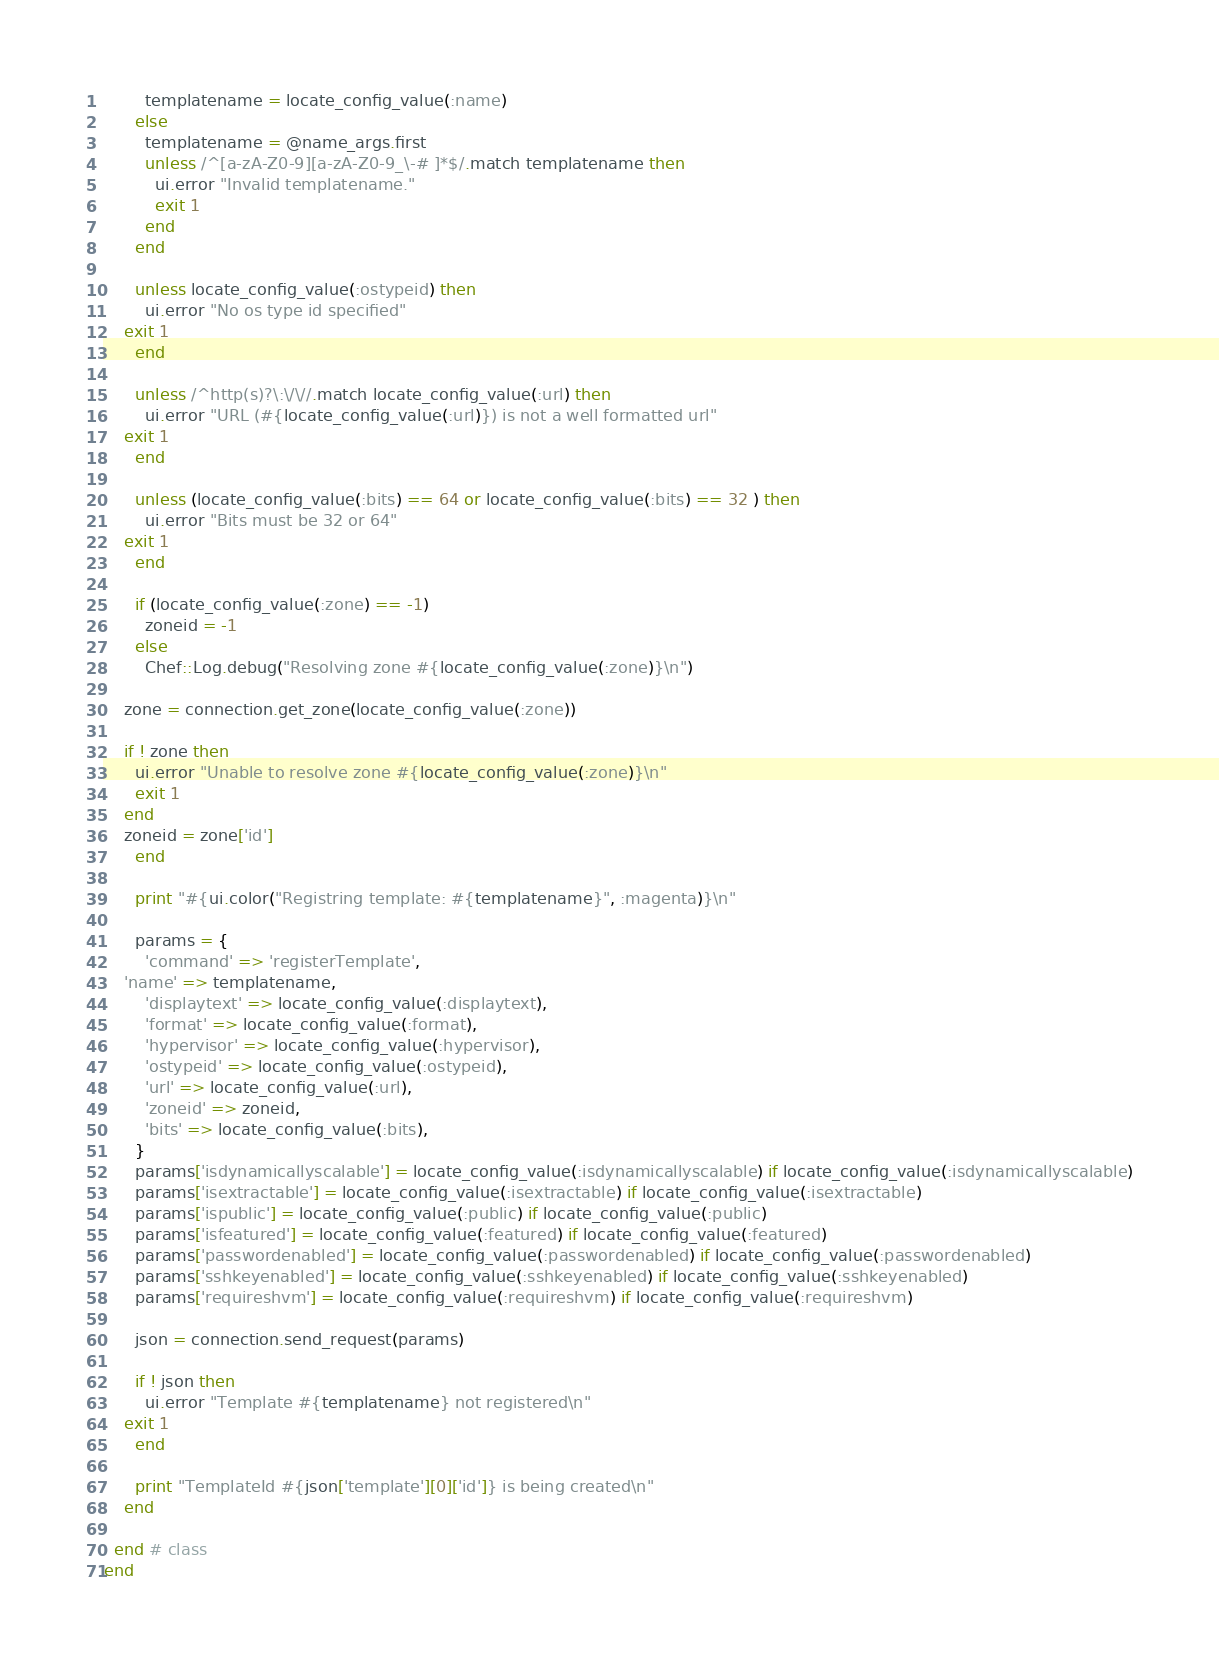<code> <loc_0><loc_0><loc_500><loc_500><_Ruby_>        templatename = locate_config_value(:name)
      else
        templatename = @name_args.first
        unless /^[a-zA-Z0-9][a-zA-Z0-9_\-# ]*$/.match templatename then
          ui.error "Invalid templatename."
          exit 1
        end
      end

      unless locate_config_value(:ostypeid) then
        ui.error "No os type id specified"
	exit 1
      end
      
      unless /^http(s)?\:\/\//.match locate_config_value(:url) then
        ui.error "URL (#{locate_config_value(:url)}) is not a well formatted url"
	exit 1
      end

      unless (locate_config_value(:bits) == 64 or locate_config_value(:bits) == 32 ) then
        ui.error "Bits must be 32 or 64"
	exit 1
      end

      if (locate_config_value(:zone) == -1)
        zoneid = -1
      else
      	Chef::Log.debug("Resolving zone #{locate_config_value(:zone)}\n")

	zone = connection.get_zone(locate_config_value(:zone))

	if ! zone then
	  ui.error "Unable to resolve zone #{locate_config_value(:zone)}\n"
	  exit 1
	end
	zoneid = zone['id']
      end

      print "#{ui.color("Registring template: #{templatename}", :magenta)}\n"

      params = {
        'command' => 'registerTemplate',
	'name' => templatename,
        'displaytext' => locate_config_value(:displaytext),
        'format' => locate_config_value(:format),
        'hypervisor' => locate_config_value(:hypervisor),
        'ostypeid' => locate_config_value(:ostypeid),
        'url' => locate_config_value(:url),
        'zoneid' => zoneid,
        'bits' => locate_config_value(:bits),
      }
      params['isdynamicallyscalable'] = locate_config_value(:isdynamicallyscalable) if locate_config_value(:isdynamicallyscalable)
      params['isextractable'] = locate_config_value(:isextractable) if locate_config_value(:isextractable)
      params['ispublic'] = locate_config_value(:public) if locate_config_value(:public)
      params['isfeatured'] = locate_config_value(:featured) if locate_config_value(:featured)
      params['passwordenabled'] = locate_config_value(:passwordenabled) if locate_config_value(:passwordenabled)
      params['sshkeyenabled'] = locate_config_value(:sshkeyenabled) if locate_config_value(:sshkeyenabled)
      params['requireshvm'] = locate_config_value(:requireshvm) if locate_config_value(:requireshvm)

      json = connection.send_request(params)

      if ! json then
        ui.error "Template #{templatename} not registered\n"
	exit 1
      end

      print "TemplateId #{json['template'][0]['id']} is being created\n"
    end

  end # class
end
</code> 